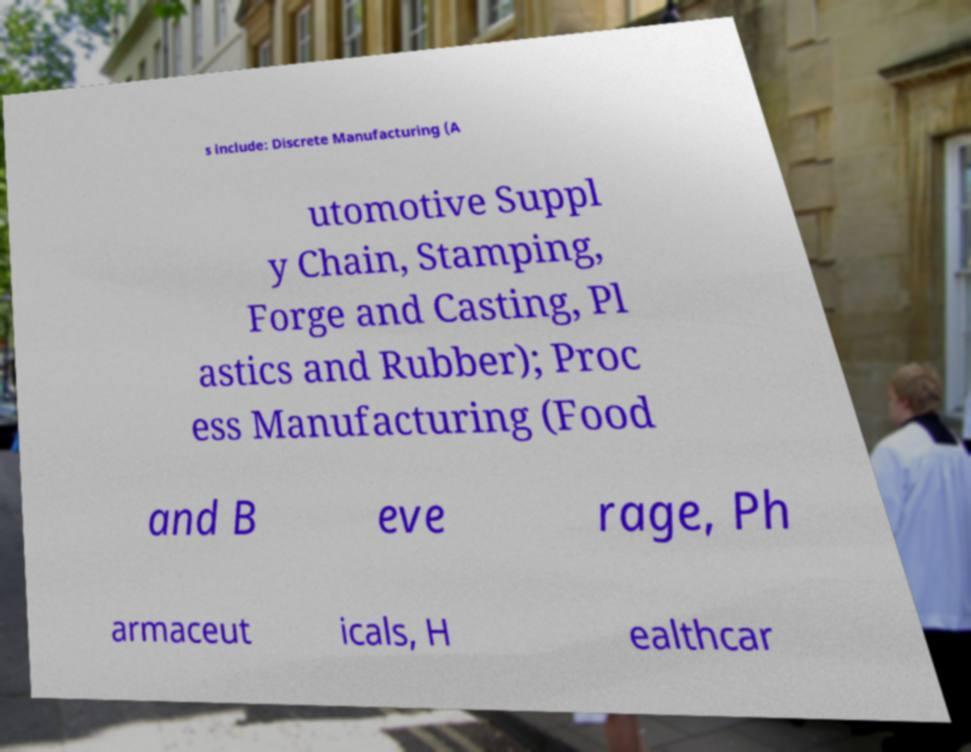There's text embedded in this image that I need extracted. Can you transcribe it verbatim? s include: Discrete Manufacturing (A utomotive Suppl y Chain, Stamping, Forge and Casting, Pl astics and Rubber); Proc ess Manufacturing (Food and B eve rage, Ph armaceut icals, H ealthcar 